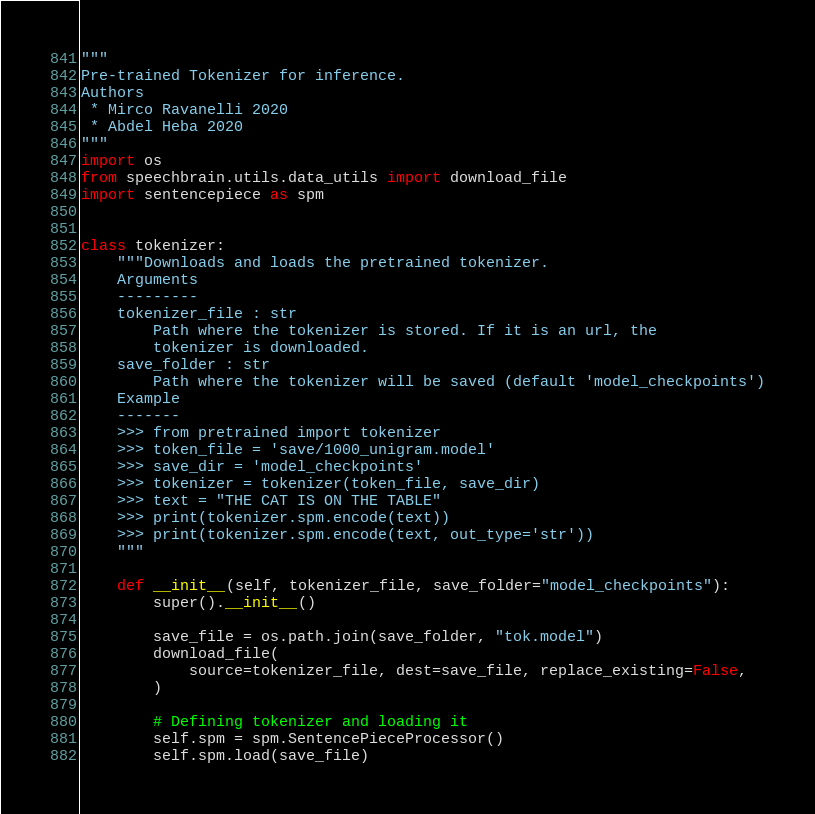Convert code to text. <code><loc_0><loc_0><loc_500><loc_500><_Python_>"""
Pre-trained Tokenizer for inference.
Authors
 * Mirco Ravanelli 2020
 * Abdel Heba 2020
"""
import os
from speechbrain.utils.data_utils import download_file
import sentencepiece as spm


class tokenizer:
    """Downloads and loads the pretrained tokenizer.
    Arguments
    ---------
    tokenizer_file : str
        Path where the tokenizer is stored. If it is an url, the
        tokenizer is downloaded.
    save_folder : str
        Path where the tokenizer will be saved (default 'model_checkpoints')
    Example
    -------
    >>> from pretrained import tokenizer
    >>> token_file = 'save/1000_unigram.model'
    >>> save_dir = 'model_checkpoints'
    >>> tokenizer = tokenizer(token_file, save_dir)
    >>> text = "THE CAT IS ON THE TABLE"
    >>> print(tokenizer.spm.encode(text))
    >>> print(tokenizer.spm.encode(text, out_type='str'))
    """

    def __init__(self, tokenizer_file, save_folder="model_checkpoints"):
        super().__init__()

        save_file = os.path.join(save_folder, "tok.model")
        download_file(
            source=tokenizer_file, dest=save_file, replace_existing=False,
        )

        # Defining tokenizer and loading it
        self.spm = spm.SentencePieceProcessor()
        self.spm.load(save_file)
</code> 